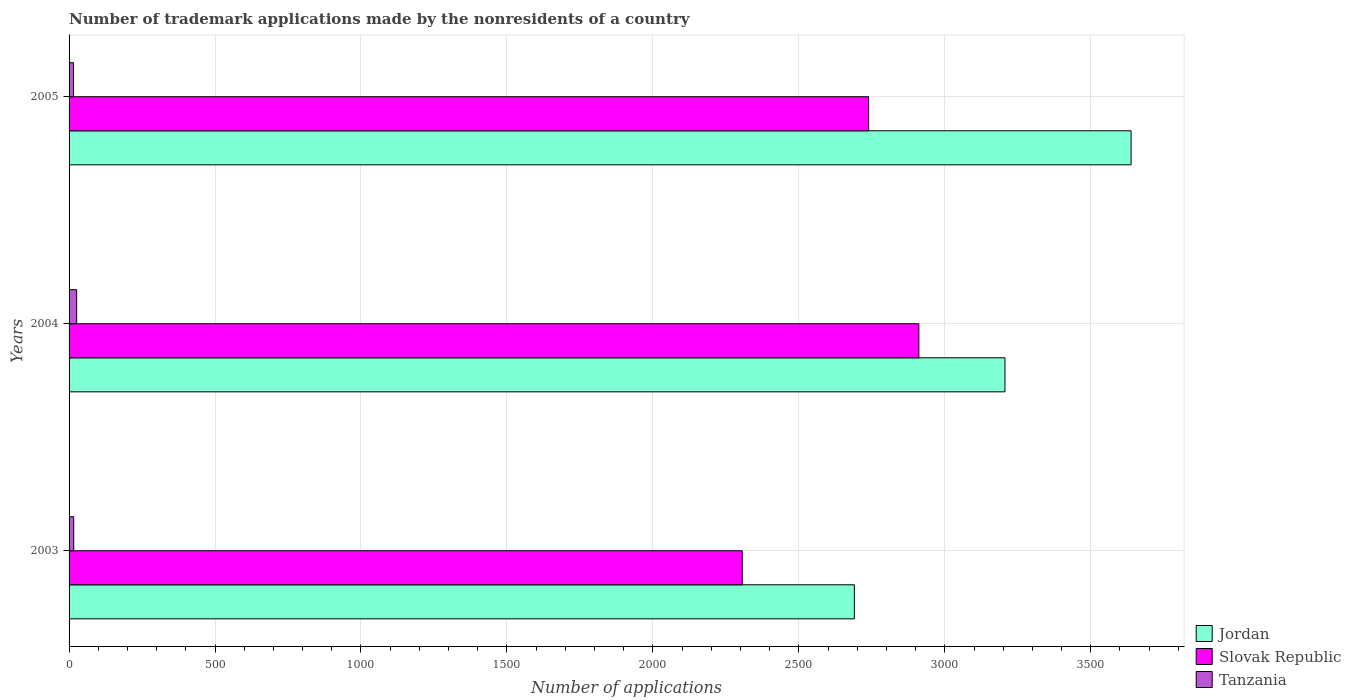How many different coloured bars are there?
Keep it short and to the point. 3. Are the number of bars per tick equal to the number of legend labels?
Make the answer very short. Yes. How many bars are there on the 2nd tick from the top?
Your response must be concise. 3. How many bars are there on the 1st tick from the bottom?
Ensure brevity in your answer.  3. What is the label of the 1st group of bars from the top?
Your answer should be very brief. 2005. In how many cases, is the number of bars for a given year not equal to the number of legend labels?
Keep it short and to the point. 0. What is the number of trademark applications made by the nonresidents in Slovak Republic in 2004?
Provide a short and direct response. 2911. Across all years, what is the maximum number of trademark applications made by the nonresidents in Slovak Republic?
Your answer should be very brief. 2911. Across all years, what is the minimum number of trademark applications made by the nonresidents in Tanzania?
Make the answer very short. 15. What is the total number of trademark applications made by the nonresidents in Jordan in the graph?
Make the answer very short. 9534. What is the average number of trademark applications made by the nonresidents in Tanzania per year?
Your response must be concise. 19. In the year 2004, what is the difference between the number of trademark applications made by the nonresidents in Tanzania and number of trademark applications made by the nonresidents in Jordan?
Your answer should be very brief. -3180. In how many years, is the number of trademark applications made by the nonresidents in Tanzania greater than 1100 ?
Offer a very short reply. 0. What is the ratio of the number of trademark applications made by the nonresidents in Slovak Republic in 2003 to that in 2004?
Give a very brief answer. 0.79. Is the number of trademark applications made by the nonresidents in Slovak Republic in 2003 less than that in 2004?
Your response must be concise. Yes. Is the difference between the number of trademark applications made by the nonresidents in Tanzania in 2003 and 2004 greater than the difference between the number of trademark applications made by the nonresidents in Jordan in 2003 and 2004?
Keep it short and to the point. Yes. What is the difference between the highest and the second highest number of trademark applications made by the nonresidents in Slovak Republic?
Make the answer very short. 172. What is the difference between the highest and the lowest number of trademark applications made by the nonresidents in Tanzania?
Ensure brevity in your answer.  11. In how many years, is the number of trademark applications made by the nonresidents in Slovak Republic greater than the average number of trademark applications made by the nonresidents in Slovak Republic taken over all years?
Keep it short and to the point. 2. What does the 1st bar from the top in 2004 represents?
Provide a short and direct response. Tanzania. What does the 3rd bar from the bottom in 2003 represents?
Your answer should be very brief. Tanzania. How many years are there in the graph?
Your answer should be very brief. 3. What is the difference between two consecutive major ticks on the X-axis?
Keep it short and to the point. 500. Does the graph contain any zero values?
Give a very brief answer. No. Does the graph contain grids?
Your answer should be compact. Yes. How are the legend labels stacked?
Ensure brevity in your answer.  Vertical. What is the title of the graph?
Provide a succinct answer. Number of trademark applications made by the nonresidents of a country. Does "Cayman Islands" appear as one of the legend labels in the graph?
Offer a very short reply. No. What is the label or title of the X-axis?
Make the answer very short. Number of applications. What is the Number of applications in Jordan in 2003?
Keep it short and to the point. 2690. What is the Number of applications in Slovak Republic in 2003?
Provide a succinct answer. 2306. What is the Number of applications in Tanzania in 2003?
Offer a very short reply. 16. What is the Number of applications of Jordan in 2004?
Offer a terse response. 3206. What is the Number of applications of Slovak Republic in 2004?
Ensure brevity in your answer.  2911. What is the Number of applications in Tanzania in 2004?
Offer a very short reply. 26. What is the Number of applications of Jordan in 2005?
Provide a short and direct response. 3638. What is the Number of applications of Slovak Republic in 2005?
Your response must be concise. 2739. What is the Number of applications of Tanzania in 2005?
Provide a short and direct response. 15. Across all years, what is the maximum Number of applications in Jordan?
Your response must be concise. 3638. Across all years, what is the maximum Number of applications of Slovak Republic?
Keep it short and to the point. 2911. Across all years, what is the maximum Number of applications of Tanzania?
Your answer should be very brief. 26. Across all years, what is the minimum Number of applications in Jordan?
Give a very brief answer. 2690. Across all years, what is the minimum Number of applications in Slovak Republic?
Offer a very short reply. 2306. What is the total Number of applications of Jordan in the graph?
Provide a succinct answer. 9534. What is the total Number of applications in Slovak Republic in the graph?
Give a very brief answer. 7956. What is the difference between the Number of applications in Jordan in 2003 and that in 2004?
Make the answer very short. -516. What is the difference between the Number of applications in Slovak Republic in 2003 and that in 2004?
Offer a very short reply. -605. What is the difference between the Number of applications of Jordan in 2003 and that in 2005?
Offer a very short reply. -948. What is the difference between the Number of applications of Slovak Republic in 2003 and that in 2005?
Ensure brevity in your answer.  -433. What is the difference between the Number of applications in Tanzania in 2003 and that in 2005?
Make the answer very short. 1. What is the difference between the Number of applications of Jordan in 2004 and that in 2005?
Offer a terse response. -432. What is the difference between the Number of applications of Slovak Republic in 2004 and that in 2005?
Ensure brevity in your answer.  172. What is the difference between the Number of applications of Tanzania in 2004 and that in 2005?
Your answer should be very brief. 11. What is the difference between the Number of applications of Jordan in 2003 and the Number of applications of Slovak Republic in 2004?
Your answer should be very brief. -221. What is the difference between the Number of applications of Jordan in 2003 and the Number of applications of Tanzania in 2004?
Keep it short and to the point. 2664. What is the difference between the Number of applications in Slovak Republic in 2003 and the Number of applications in Tanzania in 2004?
Your response must be concise. 2280. What is the difference between the Number of applications in Jordan in 2003 and the Number of applications in Slovak Republic in 2005?
Keep it short and to the point. -49. What is the difference between the Number of applications in Jordan in 2003 and the Number of applications in Tanzania in 2005?
Provide a succinct answer. 2675. What is the difference between the Number of applications in Slovak Republic in 2003 and the Number of applications in Tanzania in 2005?
Offer a very short reply. 2291. What is the difference between the Number of applications in Jordan in 2004 and the Number of applications in Slovak Republic in 2005?
Your answer should be very brief. 467. What is the difference between the Number of applications in Jordan in 2004 and the Number of applications in Tanzania in 2005?
Provide a succinct answer. 3191. What is the difference between the Number of applications of Slovak Republic in 2004 and the Number of applications of Tanzania in 2005?
Your answer should be compact. 2896. What is the average Number of applications of Jordan per year?
Offer a very short reply. 3178. What is the average Number of applications of Slovak Republic per year?
Provide a short and direct response. 2652. In the year 2003, what is the difference between the Number of applications in Jordan and Number of applications in Slovak Republic?
Your answer should be very brief. 384. In the year 2003, what is the difference between the Number of applications in Jordan and Number of applications in Tanzania?
Make the answer very short. 2674. In the year 2003, what is the difference between the Number of applications of Slovak Republic and Number of applications of Tanzania?
Your answer should be very brief. 2290. In the year 2004, what is the difference between the Number of applications of Jordan and Number of applications of Slovak Republic?
Keep it short and to the point. 295. In the year 2004, what is the difference between the Number of applications in Jordan and Number of applications in Tanzania?
Make the answer very short. 3180. In the year 2004, what is the difference between the Number of applications in Slovak Republic and Number of applications in Tanzania?
Give a very brief answer. 2885. In the year 2005, what is the difference between the Number of applications of Jordan and Number of applications of Slovak Republic?
Ensure brevity in your answer.  899. In the year 2005, what is the difference between the Number of applications of Jordan and Number of applications of Tanzania?
Your answer should be compact. 3623. In the year 2005, what is the difference between the Number of applications of Slovak Republic and Number of applications of Tanzania?
Keep it short and to the point. 2724. What is the ratio of the Number of applications in Jordan in 2003 to that in 2004?
Your answer should be compact. 0.84. What is the ratio of the Number of applications in Slovak Republic in 2003 to that in 2004?
Ensure brevity in your answer.  0.79. What is the ratio of the Number of applications in Tanzania in 2003 to that in 2004?
Offer a terse response. 0.62. What is the ratio of the Number of applications in Jordan in 2003 to that in 2005?
Your answer should be very brief. 0.74. What is the ratio of the Number of applications of Slovak Republic in 2003 to that in 2005?
Your answer should be compact. 0.84. What is the ratio of the Number of applications in Tanzania in 2003 to that in 2005?
Offer a very short reply. 1.07. What is the ratio of the Number of applications of Jordan in 2004 to that in 2005?
Your answer should be compact. 0.88. What is the ratio of the Number of applications of Slovak Republic in 2004 to that in 2005?
Your answer should be compact. 1.06. What is the ratio of the Number of applications in Tanzania in 2004 to that in 2005?
Ensure brevity in your answer.  1.73. What is the difference between the highest and the second highest Number of applications of Jordan?
Provide a short and direct response. 432. What is the difference between the highest and the second highest Number of applications of Slovak Republic?
Your answer should be very brief. 172. What is the difference between the highest and the second highest Number of applications of Tanzania?
Offer a terse response. 10. What is the difference between the highest and the lowest Number of applications in Jordan?
Make the answer very short. 948. What is the difference between the highest and the lowest Number of applications of Slovak Republic?
Your response must be concise. 605. 